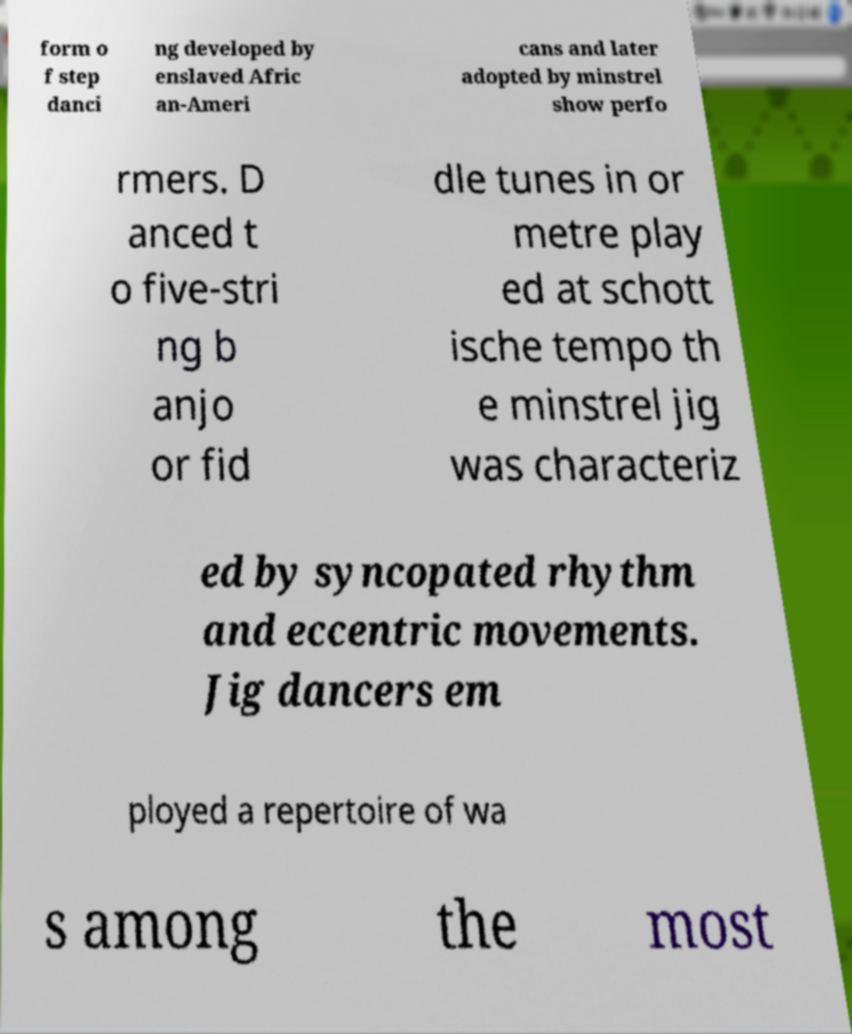For documentation purposes, I need the text within this image transcribed. Could you provide that? form o f step danci ng developed by enslaved Afric an-Ameri cans and later adopted by minstrel show perfo rmers. D anced t o five-stri ng b anjo or fid dle tunes in or metre play ed at schott ische tempo th e minstrel jig was characteriz ed by syncopated rhythm and eccentric movements. Jig dancers em ployed a repertoire of wa s among the most 